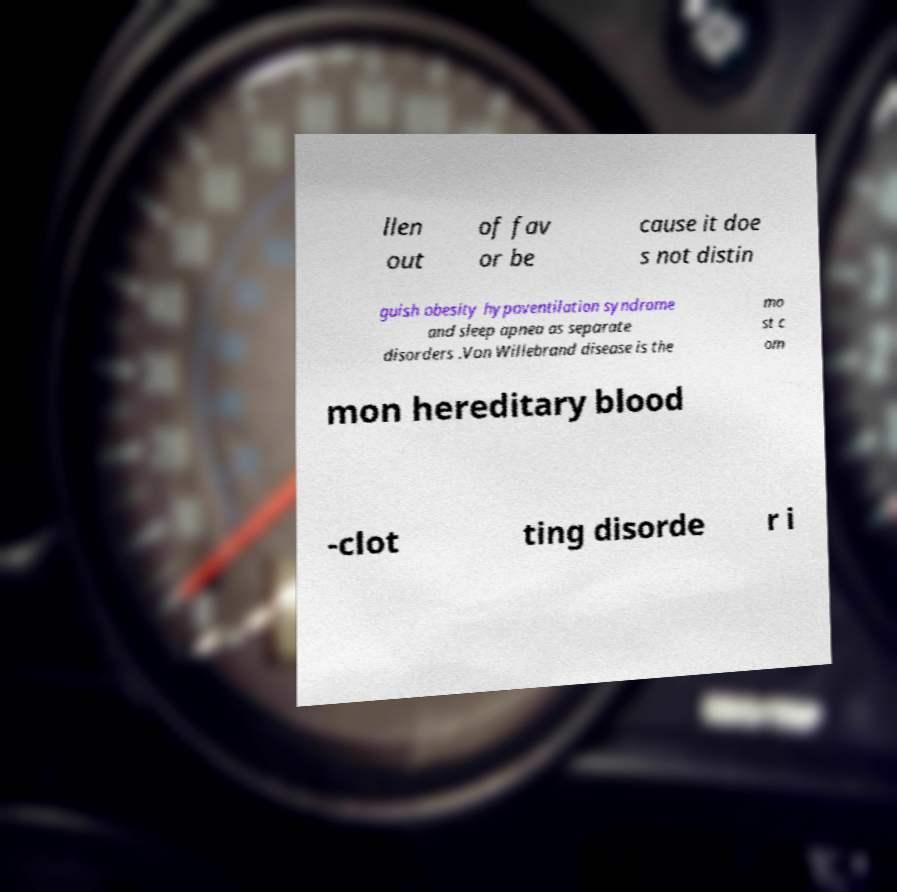Can you accurately transcribe the text from the provided image for me? llen out of fav or be cause it doe s not distin guish obesity hypoventilation syndrome and sleep apnea as separate disorders .Von Willebrand disease is the mo st c om mon hereditary blood -clot ting disorde r i 